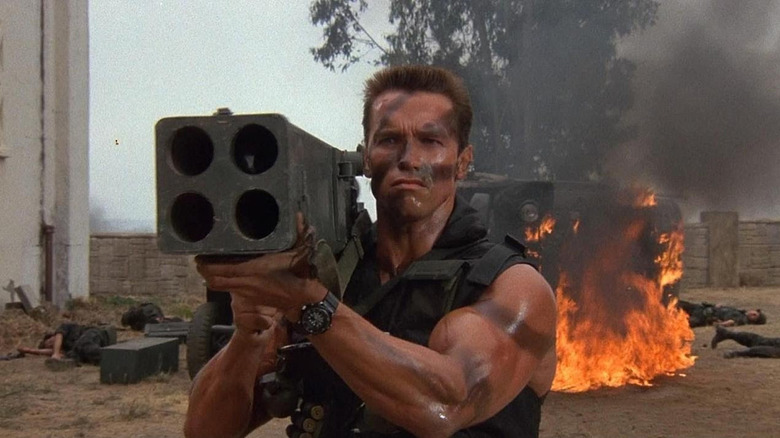Could you describe the significance of the weapon he is holding? The weapon, a large rocket launcher, symbolizes significant firepower and the capacity to engage powerful enemies or obstacles. Its presence in the scene underscores the severity of the conflict and the extreme measures required to address it, highlighting the character's role as a formidable combatant. 